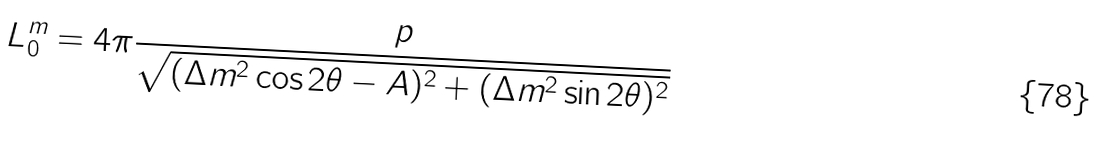Convert formula to latex. <formula><loc_0><loc_0><loc_500><loc_500>L _ { 0 } ^ { m } = 4 \pi \frac { p } { \sqrt { ( \Delta m ^ { 2 } \cos 2 \theta - A ) ^ { 2 } + ( \Delta m ^ { 2 } \sin 2 \theta ) ^ { 2 } } }</formula> 